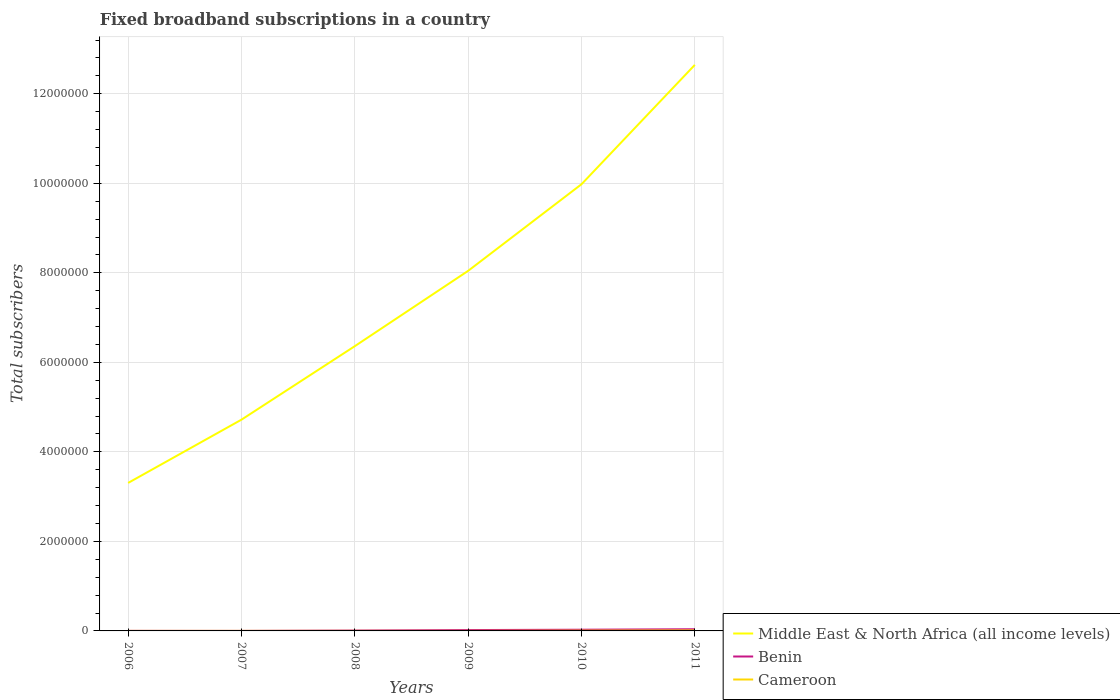How many different coloured lines are there?
Provide a short and direct response. 3. Does the line corresponding to Benin intersect with the line corresponding to Middle East & North Africa (all income levels)?
Your answer should be very brief. No. Is the number of lines equal to the number of legend labels?
Provide a short and direct response. Yes. Across all years, what is the maximum number of broadband subscriptions in Middle East & North Africa (all income levels)?
Your answer should be very brief. 3.31e+06. In which year was the number of broadband subscriptions in Benin maximum?
Ensure brevity in your answer.  2007. What is the total number of broadband subscriptions in Benin in the graph?
Provide a succinct answer. -7973. What is the difference between the highest and the second highest number of broadband subscriptions in Benin?
Offer a terse response. 3.68e+04. How many lines are there?
Keep it short and to the point. 3. How many years are there in the graph?
Keep it short and to the point. 6. What is the difference between two consecutive major ticks on the Y-axis?
Provide a short and direct response. 2.00e+06. Are the values on the major ticks of Y-axis written in scientific E-notation?
Your response must be concise. No. Does the graph contain any zero values?
Your response must be concise. No. How many legend labels are there?
Offer a very short reply. 3. How are the legend labels stacked?
Your response must be concise. Vertical. What is the title of the graph?
Offer a terse response. Fixed broadband subscriptions in a country. Does "Lao PDR" appear as one of the legend labels in the graph?
Offer a terse response. No. What is the label or title of the X-axis?
Ensure brevity in your answer.  Years. What is the label or title of the Y-axis?
Provide a short and direct response. Total subscribers. What is the Total subscribers of Middle East & North Africa (all income levels) in 2006?
Provide a succinct answer. 3.31e+06. What is the Total subscribers of Benin in 2006?
Offer a terse response. 1498. What is the Total subscribers in Cameroon in 2006?
Your response must be concise. 421. What is the Total subscribers of Middle East & North Africa (all income levels) in 2007?
Give a very brief answer. 4.72e+06. What is the Total subscribers of Benin in 2007?
Provide a succinct answer. 710. What is the Total subscribers of Cameroon in 2007?
Your answer should be compact. 640. What is the Total subscribers in Middle East & North Africa (all income levels) in 2008?
Provide a short and direct response. 6.36e+06. What is the Total subscribers in Benin in 2008?
Make the answer very short. 8424. What is the Total subscribers in Cameroon in 2008?
Your answer should be very brief. 860. What is the Total subscribers of Middle East & North Africa (all income levels) in 2009?
Offer a terse response. 8.04e+06. What is the Total subscribers of Benin in 2009?
Keep it short and to the point. 1.91e+04. What is the Total subscribers in Cameroon in 2009?
Offer a very short reply. 900. What is the Total subscribers in Middle East & North Africa (all income levels) in 2010?
Provide a succinct answer. 9.98e+06. What is the Total subscribers in Benin in 2010?
Make the answer very short. 2.70e+04. What is the Total subscribers in Cameroon in 2010?
Give a very brief answer. 5954. What is the Total subscribers of Middle East & North Africa (all income levels) in 2011?
Provide a short and direct response. 1.26e+07. What is the Total subscribers in Benin in 2011?
Offer a very short reply. 3.75e+04. What is the Total subscribers in Cameroon in 2011?
Your answer should be very brief. 1.07e+04. Across all years, what is the maximum Total subscribers of Middle East & North Africa (all income levels)?
Your response must be concise. 1.26e+07. Across all years, what is the maximum Total subscribers of Benin?
Your answer should be very brief. 3.75e+04. Across all years, what is the maximum Total subscribers of Cameroon?
Your answer should be very brief. 1.07e+04. Across all years, what is the minimum Total subscribers in Middle East & North Africa (all income levels)?
Your response must be concise. 3.31e+06. Across all years, what is the minimum Total subscribers of Benin?
Make the answer very short. 710. Across all years, what is the minimum Total subscribers of Cameroon?
Your response must be concise. 421. What is the total Total subscribers of Middle East & North Africa (all income levels) in the graph?
Keep it short and to the point. 4.51e+07. What is the total Total subscribers in Benin in the graph?
Give a very brief answer. 9.43e+04. What is the total Total subscribers of Cameroon in the graph?
Give a very brief answer. 1.95e+04. What is the difference between the Total subscribers in Middle East & North Africa (all income levels) in 2006 and that in 2007?
Your answer should be very brief. -1.41e+06. What is the difference between the Total subscribers of Benin in 2006 and that in 2007?
Your response must be concise. 788. What is the difference between the Total subscribers of Cameroon in 2006 and that in 2007?
Your response must be concise. -219. What is the difference between the Total subscribers of Middle East & North Africa (all income levels) in 2006 and that in 2008?
Make the answer very short. -3.06e+06. What is the difference between the Total subscribers of Benin in 2006 and that in 2008?
Your answer should be compact. -6926. What is the difference between the Total subscribers in Cameroon in 2006 and that in 2008?
Provide a succinct answer. -439. What is the difference between the Total subscribers in Middle East & North Africa (all income levels) in 2006 and that in 2009?
Your answer should be compact. -4.74e+06. What is the difference between the Total subscribers in Benin in 2006 and that in 2009?
Your answer should be very brief. -1.76e+04. What is the difference between the Total subscribers of Cameroon in 2006 and that in 2009?
Make the answer very short. -479. What is the difference between the Total subscribers of Middle East & North Africa (all income levels) in 2006 and that in 2010?
Your answer should be compact. -6.67e+06. What is the difference between the Total subscribers of Benin in 2006 and that in 2010?
Provide a succinct answer. -2.55e+04. What is the difference between the Total subscribers in Cameroon in 2006 and that in 2010?
Ensure brevity in your answer.  -5533. What is the difference between the Total subscribers of Middle East & North Africa (all income levels) in 2006 and that in 2011?
Offer a very short reply. -9.34e+06. What is the difference between the Total subscribers in Benin in 2006 and that in 2011?
Provide a short and direct response. -3.60e+04. What is the difference between the Total subscribers in Cameroon in 2006 and that in 2011?
Give a very brief answer. -1.03e+04. What is the difference between the Total subscribers in Middle East & North Africa (all income levels) in 2007 and that in 2008?
Keep it short and to the point. -1.64e+06. What is the difference between the Total subscribers in Benin in 2007 and that in 2008?
Provide a short and direct response. -7714. What is the difference between the Total subscribers in Cameroon in 2007 and that in 2008?
Ensure brevity in your answer.  -220. What is the difference between the Total subscribers in Middle East & North Africa (all income levels) in 2007 and that in 2009?
Your answer should be compact. -3.32e+06. What is the difference between the Total subscribers in Benin in 2007 and that in 2009?
Provide a short and direct response. -1.84e+04. What is the difference between the Total subscribers of Cameroon in 2007 and that in 2009?
Keep it short and to the point. -260. What is the difference between the Total subscribers of Middle East & North Africa (all income levels) in 2007 and that in 2010?
Your answer should be compact. -5.26e+06. What is the difference between the Total subscribers of Benin in 2007 and that in 2010?
Offer a terse response. -2.63e+04. What is the difference between the Total subscribers of Cameroon in 2007 and that in 2010?
Offer a very short reply. -5314. What is the difference between the Total subscribers of Middle East & North Africa (all income levels) in 2007 and that in 2011?
Your answer should be compact. -7.93e+06. What is the difference between the Total subscribers of Benin in 2007 and that in 2011?
Make the answer very short. -3.68e+04. What is the difference between the Total subscribers in Cameroon in 2007 and that in 2011?
Ensure brevity in your answer.  -1.01e+04. What is the difference between the Total subscribers in Middle East & North Africa (all income levels) in 2008 and that in 2009?
Keep it short and to the point. -1.68e+06. What is the difference between the Total subscribers of Benin in 2008 and that in 2009?
Your answer should be compact. -1.06e+04. What is the difference between the Total subscribers of Middle East & North Africa (all income levels) in 2008 and that in 2010?
Your response must be concise. -3.62e+06. What is the difference between the Total subscribers of Benin in 2008 and that in 2010?
Make the answer very short. -1.86e+04. What is the difference between the Total subscribers of Cameroon in 2008 and that in 2010?
Offer a very short reply. -5094. What is the difference between the Total subscribers in Middle East & North Africa (all income levels) in 2008 and that in 2011?
Offer a very short reply. -6.28e+06. What is the difference between the Total subscribers in Benin in 2008 and that in 2011?
Keep it short and to the point. -2.91e+04. What is the difference between the Total subscribers of Cameroon in 2008 and that in 2011?
Offer a terse response. -9853. What is the difference between the Total subscribers of Middle East & North Africa (all income levels) in 2009 and that in 2010?
Provide a succinct answer. -1.93e+06. What is the difference between the Total subscribers of Benin in 2009 and that in 2010?
Your answer should be compact. -7973. What is the difference between the Total subscribers in Cameroon in 2009 and that in 2010?
Make the answer very short. -5054. What is the difference between the Total subscribers of Middle East & North Africa (all income levels) in 2009 and that in 2011?
Your response must be concise. -4.60e+06. What is the difference between the Total subscribers in Benin in 2009 and that in 2011?
Your answer should be very brief. -1.85e+04. What is the difference between the Total subscribers of Cameroon in 2009 and that in 2011?
Ensure brevity in your answer.  -9813. What is the difference between the Total subscribers in Middle East & North Africa (all income levels) in 2010 and that in 2011?
Keep it short and to the point. -2.67e+06. What is the difference between the Total subscribers in Benin in 2010 and that in 2011?
Make the answer very short. -1.05e+04. What is the difference between the Total subscribers of Cameroon in 2010 and that in 2011?
Offer a very short reply. -4759. What is the difference between the Total subscribers of Middle East & North Africa (all income levels) in 2006 and the Total subscribers of Benin in 2007?
Keep it short and to the point. 3.31e+06. What is the difference between the Total subscribers of Middle East & North Africa (all income levels) in 2006 and the Total subscribers of Cameroon in 2007?
Provide a short and direct response. 3.31e+06. What is the difference between the Total subscribers of Benin in 2006 and the Total subscribers of Cameroon in 2007?
Ensure brevity in your answer.  858. What is the difference between the Total subscribers of Middle East & North Africa (all income levels) in 2006 and the Total subscribers of Benin in 2008?
Give a very brief answer. 3.30e+06. What is the difference between the Total subscribers in Middle East & North Africa (all income levels) in 2006 and the Total subscribers in Cameroon in 2008?
Ensure brevity in your answer.  3.31e+06. What is the difference between the Total subscribers of Benin in 2006 and the Total subscribers of Cameroon in 2008?
Ensure brevity in your answer.  638. What is the difference between the Total subscribers of Middle East & North Africa (all income levels) in 2006 and the Total subscribers of Benin in 2009?
Give a very brief answer. 3.29e+06. What is the difference between the Total subscribers in Middle East & North Africa (all income levels) in 2006 and the Total subscribers in Cameroon in 2009?
Offer a terse response. 3.31e+06. What is the difference between the Total subscribers of Benin in 2006 and the Total subscribers of Cameroon in 2009?
Offer a very short reply. 598. What is the difference between the Total subscribers of Middle East & North Africa (all income levels) in 2006 and the Total subscribers of Benin in 2010?
Give a very brief answer. 3.28e+06. What is the difference between the Total subscribers in Middle East & North Africa (all income levels) in 2006 and the Total subscribers in Cameroon in 2010?
Make the answer very short. 3.30e+06. What is the difference between the Total subscribers of Benin in 2006 and the Total subscribers of Cameroon in 2010?
Your response must be concise. -4456. What is the difference between the Total subscribers in Middle East & North Africa (all income levels) in 2006 and the Total subscribers in Benin in 2011?
Keep it short and to the point. 3.27e+06. What is the difference between the Total subscribers in Middle East & North Africa (all income levels) in 2006 and the Total subscribers in Cameroon in 2011?
Ensure brevity in your answer.  3.30e+06. What is the difference between the Total subscribers in Benin in 2006 and the Total subscribers in Cameroon in 2011?
Ensure brevity in your answer.  -9215. What is the difference between the Total subscribers in Middle East & North Africa (all income levels) in 2007 and the Total subscribers in Benin in 2008?
Provide a short and direct response. 4.71e+06. What is the difference between the Total subscribers in Middle East & North Africa (all income levels) in 2007 and the Total subscribers in Cameroon in 2008?
Your answer should be very brief. 4.72e+06. What is the difference between the Total subscribers of Benin in 2007 and the Total subscribers of Cameroon in 2008?
Provide a succinct answer. -150. What is the difference between the Total subscribers in Middle East & North Africa (all income levels) in 2007 and the Total subscribers in Benin in 2009?
Ensure brevity in your answer.  4.70e+06. What is the difference between the Total subscribers in Middle East & North Africa (all income levels) in 2007 and the Total subscribers in Cameroon in 2009?
Offer a very short reply. 4.72e+06. What is the difference between the Total subscribers of Benin in 2007 and the Total subscribers of Cameroon in 2009?
Offer a terse response. -190. What is the difference between the Total subscribers of Middle East & North Africa (all income levels) in 2007 and the Total subscribers of Benin in 2010?
Keep it short and to the point. 4.69e+06. What is the difference between the Total subscribers of Middle East & North Africa (all income levels) in 2007 and the Total subscribers of Cameroon in 2010?
Provide a short and direct response. 4.71e+06. What is the difference between the Total subscribers in Benin in 2007 and the Total subscribers in Cameroon in 2010?
Your response must be concise. -5244. What is the difference between the Total subscribers in Middle East & North Africa (all income levels) in 2007 and the Total subscribers in Benin in 2011?
Your response must be concise. 4.68e+06. What is the difference between the Total subscribers of Middle East & North Africa (all income levels) in 2007 and the Total subscribers of Cameroon in 2011?
Keep it short and to the point. 4.71e+06. What is the difference between the Total subscribers in Benin in 2007 and the Total subscribers in Cameroon in 2011?
Offer a very short reply. -1.00e+04. What is the difference between the Total subscribers of Middle East & North Africa (all income levels) in 2008 and the Total subscribers of Benin in 2009?
Provide a short and direct response. 6.34e+06. What is the difference between the Total subscribers in Middle East & North Africa (all income levels) in 2008 and the Total subscribers in Cameroon in 2009?
Offer a terse response. 6.36e+06. What is the difference between the Total subscribers in Benin in 2008 and the Total subscribers in Cameroon in 2009?
Provide a succinct answer. 7524. What is the difference between the Total subscribers of Middle East & North Africa (all income levels) in 2008 and the Total subscribers of Benin in 2010?
Offer a terse response. 6.34e+06. What is the difference between the Total subscribers in Middle East & North Africa (all income levels) in 2008 and the Total subscribers in Cameroon in 2010?
Give a very brief answer. 6.36e+06. What is the difference between the Total subscribers of Benin in 2008 and the Total subscribers of Cameroon in 2010?
Give a very brief answer. 2470. What is the difference between the Total subscribers in Middle East & North Africa (all income levels) in 2008 and the Total subscribers in Benin in 2011?
Your answer should be compact. 6.32e+06. What is the difference between the Total subscribers of Middle East & North Africa (all income levels) in 2008 and the Total subscribers of Cameroon in 2011?
Your response must be concise. 6.35e+06. What is the difference between the Total subscribers of Benin in 2008 and the Total subscribers of Cameroon in 2011?
Provide a short and direct response. -2289. What is the difference between the Total subscribers in Middle East & North Africa (all income levels) in 2009 and the Total subscribers in Benin in 2010?
Your response must be concise. 8.02e+06. What is the difference between the Total subscribers in Middle East & North Africa (all income levels) in 2009 and the Total subscribers in Cameroon in 2010?
Give a very brief answer. 8.04e+06. What is the difference between the Total subscribers in Benin in 2009 and the Total subscribers in Cameroon in 2010?
Make the answer very short. 1.31e+04. What is the difference between the Total subscribers in Middle East & North Africa (all income levels) in 2009 and the Total subscribers in Benin in 2011?
Your response must be concise. 8.01e+06. What is the difference between the Total subscribers in Middle East & North Africa (all income levels) in 2009 and the Total subscribers in Cameroon in 2011?
Make the answer very short. 8.03e+06. What is the difference between the Total subscribers of Benin in 2009 and the Total subscribers of Cameroon in 2011?
Keep it short and to the point. 8348. What is the difference between the Total subscribers of Middle East & North Africa (all income levels) in 2010 and the Total subscribers of Benin in 2011?
Your response must be concise. 9.94e+06. What is the difference between the Total subscribers in Middle East & North Africa (all income levels) in 2010 and the Total subscribers in Cameroon in 2011?
Your answer should be compact. 9.97e+06. What is the difference between the Total subscribers of Benin in 2010 and the Total subscribers of Cameroon in 2011?
Your answer should be compact. 1.63e+04. What is the average Total subscribers in Middle East & North Africa (all income levels) per year?
Provide a short and direct response. 7.51e+06. What is the average Total subscribers of Benin per year?
Offer a terse response. 1.57e+04. What is the average Total subscribers of Cameroon per year?
Make the answer very short. 3248. In the year 2006, what is the difference between the Total subscribers in Middle East & North Africa (all income levels) and Total subscribers in Benin?
Offer a very short reply. 3.30e+06. In the year 2006, what is the difference between the Total subscribers in Middle East & North Africa (all income levels) and Total subscribers in Cameroon?
Your response must be concise. 3.31e+06. In the year 2006, what is the difference between the Total subscribers in Benin and Total subscribers in Cameroon?
Your answer should be compact. 1077. In the year 2007, what is the difference between the Total subscribers of Middle East & North Africa (all income levels) and Total subscribers of Benin?
Offer a terse response. 4.72e+06. In the year 2007, what is the difference between the Total subscribers in Middle East & North Africa (all income levels) and Total subscribers in Cameroon?
Ensure brevity in your answer.  4.72e+06. In the year 2008, what is the difference between the Total subscribers of Middle East & North Africa (all income levels) and Total subscribers of Benin?
Your response must be concise. 6.35e+06. In the year 2008, what is the difference between the Total subscribers in Middle East & North Africa (all income levels) and Total subscribers in Cameroon?
Make the answer very short. 6.36e+06. In the year 2008, what is the difference between the Total subscribers in Benin and Total subscribers in Cameroon?
Offer a very short reply. 7564. In the year 2009, what is the difference between the Total subscribers of Middle East & North Africa (all income levels) and Total subscribers of Benin?
Provide a succinct answer. 8.03e+06. In the year 2009, what is the difference between the Total subscribers in Middle East & North Africa (all income levels) and Total subscribers in Cameroon?
Make the answer very short. 8.04e+06. In the year 2009, what is the difference between the Total subscribers in Benin and Total subscribers in Cameroon?
Provide a succinct answer. 1.82e+04. In the year 2010, what is the difference between the Total subscribers in Middle East & North Africa (all income levels) and Total subscribers in Benin?
Offer a very short reply. 9.95e+06. In the year 2010, what is the difference between the Total subscribers of Middle East & North Africa (all income levels) and Total subscribers of Cameroon?
Your answer should be very brief. 9.97e+06. In the year 2010, what is the difference between the Total subscribers in Benin and Total subscribers in Cameroon?
Your answer should be very brief. 2.11e+04. In the year 2011, what is the difference between the Total subscribers of Middle East & North Africa (all income levels) and Total subscribers of Benin?
Make the answer very short. 1.26e+07. In the year 2011, what is the difference between the Total subscribers of Middle East & North Africa (all income levels) and Total subscribers of Cameroon?
Make the answer very short. 1.26e+07. In the year 2011, what is the difference between the Total subscribers in Benin and Total subscribers in Cameroon?
Provide a succinct answer. 2.68e+04. What is the ratio of the Total subscribers of Middle East & North Africa (all income levels) in 2006 to that in 2007?
Ensure brevity in your answer.  0.7. What is the ratio of the Total subscribers in Benin in 2006 to that in 2007?
Give a very brief answer. 2.11. What is the ratio of the Total subscribers of Cameroon in 2006 to that in 2007?
Offer a very short reply. 0.66. What is the ratio of the Total subscribers in Middle East & North Africa (all income levels) in 2006 to that in 2008?
Keep it short and to the point. 0.52. What is the ratio of the Total subscribers in Benin in 2006 to that in 2008?
Provide a succinct answer. 0.18. What is the ratio of the Total subscribers of Cameroon in 2006 to that in 2008?
Ensure brevity in your answer.  0.49. What is the ratio of the Total subscribers of Middle East & North Africa (all income levels) in 2006 to that in 2009?
Provide a succinct answer. 0.41. What is the ratio of the Total subscribers in Benin in 2006 to that in 2009?
Give a very brief answer. 0.08. What is the ratio of the Total subscribers of Cameroon in 2006 to that in 2009?
Offer a very short reply. 0.47. What is the ratio of the Total subscribers of Middle East & North Africa (all income levels) in 2006 to that in 2010?
Your response must be concise. 0.33. What is the ratio of the Total subscribers of Benin in 2006 to that in 2010?
Make the answer very short. 0.06. What is the ratio of the Total subscribers of Cameroon in 2006 to that in 2010?
Your answer should be very brief. 0.07. What is the ratio of the Total subscribers of Middle East & North Africa (all income levels) in 2006 to that in 2011?
Offer a terse response. 0.26. What is the ratio of the Total subscribers of Benin in 2006 to that in 2011?
Keep it short and to the point. 0.04. What is the ratio of the Total subscribers of Cameroon in 2006 to that in 2011?
Keep it short and to the point. 0.04. What is the ratio of the Total subscribers in Middle East & North Africa (all income levels) in 2007 to that in 2008?
Give a very brief answer. 0.74. What is the ratio of the Total subscribers in Benin in 2007 to that in 2008?
Offer a terse response. 0.08. What is the ratio of the Total subscribers of Cameroon in 2007 to that in 2008?
Ensure brevity in your answer.  0.74. What is the ratio of the Total subscribers in Middle East & North Africa (all income levels) in 2007 to that in 2009?
Provide a succinct answer. 0.59. What is the ratio of the Total subscribers in Benin in 2007 to that in 2009?
Your answer should be very brief. 0.04. What is the ratio of the Total subscribers in Cameroon in 2007 to that in 2009?
Offer a terse response. 0.71. What is the ratio of the Total subscribers in Middle East & North Africa (all income levels) in 2007 to that in 2010?
Ensure brevity in your answer.  0.47. What is the ratio of the Total subscribers of Benin in 2007 to that in 2010?
Your response must be concise. 0.03. What is the ratio of the Total subscribers of Cameroon in 2007 to that in 2010?
Your answer should be compact. 0.11. What is the ratio of the Total subscribers of Middle East & North Africa (all income levels) in 2007 to that in 2011?
Give a very brief answer. 0.37. What is the ratio of the Total subscribers of Benin in 2007 to that in 2011?
Your response must be concise. 0.02. What is the ratio of the Total subscribers of Cameroon in 2007 to that in 2011?
Make the answer very short. 0.06. What is the ratio of the Total subscribers in Middle East & North Africa (all income levels) in 2008 to that in 2009?
Provide a short and direct response. 0.79. What is the ratio of the Total subscribers of Benin in 2008 to that in 2009?
Make the answer very short. 0.44. What is the ratio of the Total subscribers in Cameroon in 2008 to that in 2009?
Your response must be concise. 0.96. What is the ratio of the Total subscribers in Middle East & North Africa (all income levels) in 2008 to that in 2010?
Offer a terse response. 0.64. What is the ratio of the Total subscribers in Benin in 2008 to that in 2010?
Offer a terse response. 0.31. What is the ratio of the Total subscribers of Cameroon in 2008 to that in 2010?
Keep it short and to the point. 0.14. What is the ratio of the Total subscribers in Middle East & North Africa (all income levels) in 2008 to that in 2011?
Give a very brief answer. 0.5. What is the ratio of the Total subscribers of Benin in 2008 to that in 2011?
Your answer should be very brief. 0.22. What is the ratio of the Total subscribers of Cameroon in 2008 to that in 2011?
Give a very brief answer. 0.08. What is the ratio of the Total subscribers in Middle East & North Africa (all income levels) in 2009 to that in 2010?
Your answer should be very brief. 0.81. What is the ratio of the Total subscribers of Benin in 2009 to that in 2010?
Offer a terse response. 0.71. What is the ratio of the Total subscribers in Cameroon in 2009 to that in 2010?
Ensure brevity in your answer.  0.15. What is the ratio of the Total subscribers of Middle East & North Africa (all income levels) in 2009 to that in 2011?
Offer a very short reply. 0.64. What is the ratio of the Total subscribers of Benin in 2009 to that in 2011?
Your answer should be very brief. 0.51. What is the ratio of the Total subscribers of Cameroon in 2009 to that in 2011?
Provide a succinct answer. 0.08. What is the ratio of the Total subscribers in Middle East & North Africa (all income levels) in 2010 to that in 2011?
Ensure brevity in your answer.  0.79. What is the ratio of the Total subscribers of Benin in 2010 to that in 2011?
Offer a very short reply. 0.72. What is the ratio of the Total subscribers in Cameroon in 2010 to that in 2011?
Offer a terse response. 0.56. What is the difference between the highest and the second highest Total subscribers of Middle East & North Africa (all income levels)?
Give a very brief answer. 2.67e+06. What is the difference between the highest and the second highest Total subscribers of Benin?
Ensure brevity in your answer.  1.05e+04. What is the difference between the highest and the second highest Total subscribers of Cameroon?
Offer a very short reply. 4759. What is the difference between the highest and the lowest Total subscribers in Middle East & North Africa (all income levels)?
Offer a terse response. 9.34e+06. What is the difference between the highest and the lowest Total subscribers of Benin?
Your response must be concise. 3.68e+04. What is the difference between the highest and the lowest Total subscribers of Cameroon?
Ensure brevity in your answer.  1.03e+04. 